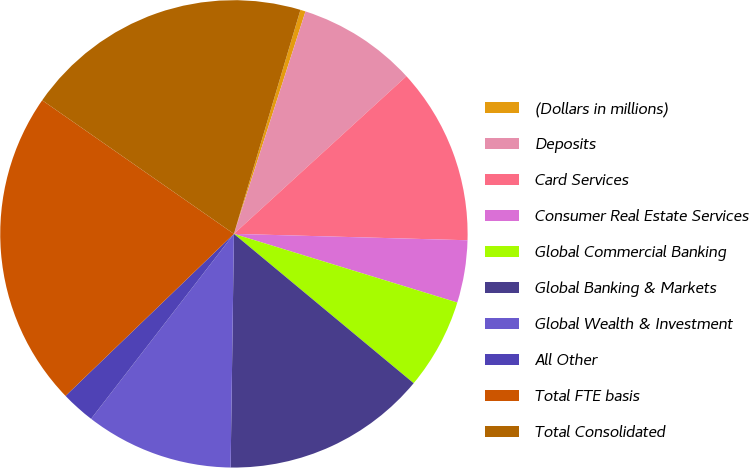<chart> <loc_0><loc_0><loc_500><loc_500><pie_chart><fcel>(Dollars in millions)<fcel>Deposits<fcel>Card Services<fcel>Consumer Real Estate Services<fcel>Global Commercial Banking<fcel>Global Banking & Markets<fcel>Global Wealth & Investment<fcel>All Other<fcel>Total FTE basis<fcel>Total Consolidated<nl><fcel>0.36%<fcel>8.26%<fcel>12.22%<fcel>4.31%<fcel>6.29%<fcel>14.19%<fcel>10.24%<fcel>2.34%<fcel>21.88%<fcel>19.91%<nl></chart> 